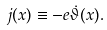<formula> <loc_0><loc_0><loc_500><loc_500>j ( x ) \equiv - e \dot { \vartheta } ( x ) .</formula> 